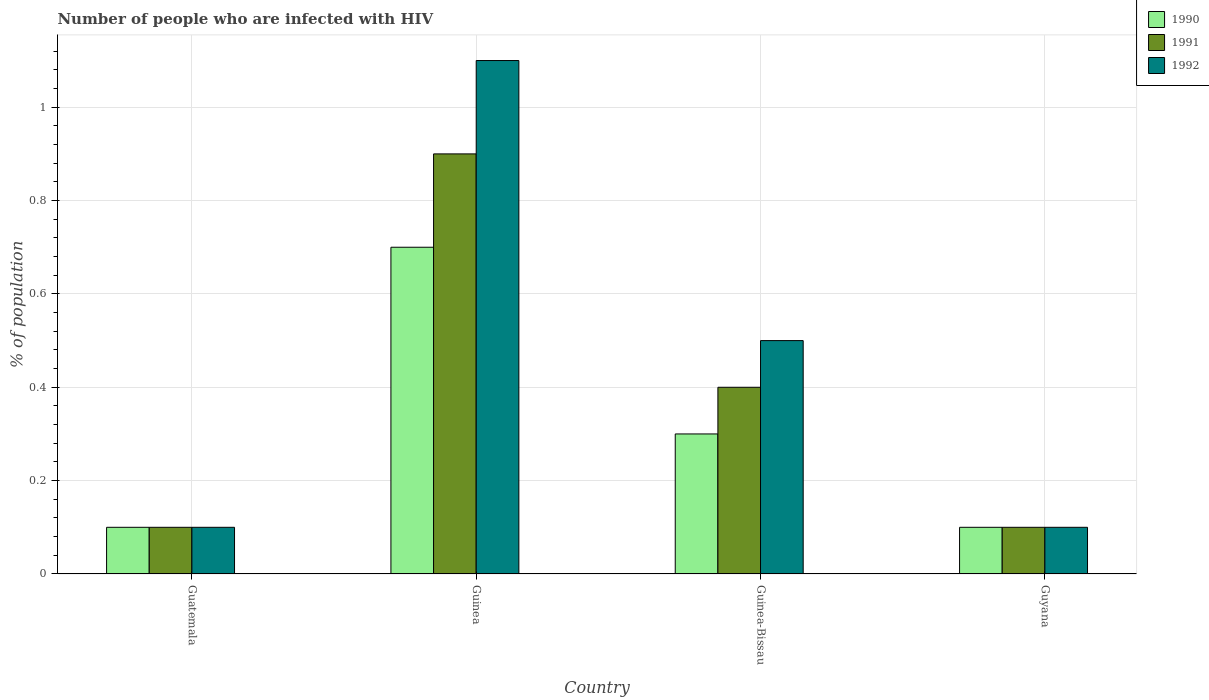How many different coloured bars are there?
Your answer should be compact. 3. How many groups of bars are there?
Keep it short and to the point. 4. Are the number of bars per tick equal to the number of legend labels?
Offer a very short reply. Yes. Are the number of bars on each tick of the X-axis equal?
Offer a terse response. Yes. What is the label of the 2nd group of bars from the left?
Make the answer very short. Guinea. In how many cases, is the number of bars for a given country not equal to the number of legend labels?
Offer a terse response. 0. In which country was the percentage of HIV infected population in in 1990 maximum?
Give a very brief answer. Guinea. In which country was the percentage of HIV infected population in in 1990 minimum?
Your response must be concise. Guatemala. What is the average percentage of HIV infected population in in 1992 per country?
Give a very brief answer. 0.45. What is the difference between the percentage of HIV infected population in of/in 1991 and percentage of HIV infected population in of/in 1992 in Guinea-Bissau?
Give a very brief answer. -0.1. In how many countries, is the percentage of HIV infected population in in 1992 greater than 0.8 %?
Your answer should be compact. 1. What is the ratio of the percentage of HIV infected population in in 1992 in Guatemala to that in Guinea?
Offer a very short reply. 0.09. Is the difference between the percentage of HIV infected population in in 1991 in Guatemala and Guinea-Bissau greater than the difference between the percentage of HIV infected population in in 1992 in Guatemala and Guinea-Bissau?
Make the answer very short. Yes. What is the difference between the highest and the second highest percentage of HIV infected population in in 1992?
Make the answer very short. -0.6. What does the 2nd bar from the left in Guatemala represents?
Ensure brevity in your answer.  1991. What does the 3rd bar from the right in Guatemala represents?
Provide a succinct answer. 1990. Is it the case that in every country, the sum of the percentage of HIV infected population in in 1991 and percentage of HIV infected population in in 1992 is greater than the percentage of HIV infected population in in 1990?
Your answer should be compact. Yes. Are all the bars in the graph horizontal?
Your answer should be very brief. No. How many countries are there in the graph?
Your answer should be compact. 4. Are the values on the major ticks of Y-axis written in scientific E-notation?
Give a very brief answer. No. Where does the legend appear in the graph?
Give a very brief answer. Top right. What is the title of the graph?
Provide a succinct answer. Number of people who are infected with HIV. What is the label or title of the Y-axis?
Ensure brevity in your answer.  % of population. What is the % of population in 1991 in Guatemala?
Provide a short and direct response. 0.1. What is the % of population in 1990 in Guinea?
Ensure brevity in your answer.  0.7. What is the % of population in 1992 in Guyana?
Make the answer very short. 0.1. Across all countries, what is the minimum % of population in 1990?
Your answer should be very brief. 0.1. Across all countries, what is the minimum % of population in 1991?
Your answer should be very brief. 0.1. What is the total % of population in 1990 in the graph?
Give a very brief answer. 1.2. What is the total % of population in 1991 in the graph?
Provide a short and direct response. 1.5. What is the difference between the % of population in 1992 in Guatemala and that in Guinea?
Your answer should be very brief. -1. What is the difference between the % of population of 1990 in Guatemala and that in Guinea-Bissau?
Provide a short and direct response. -0.2. What is the difference between the % of population in 1991 in Guatemala and that in Guyana?
Your answer should be very brief. 0. What is the difference between the % of population in 1992 in Guatemala and that in Guyana?
Make the answer very short. 0. What is the difference between the % of population of 1990 in Guinea and that in Guinea-Bissau?
Give a very brief answer. 0.4. What is the difference between the % of population in 1991 in Guinea and that in Guinea-Bissau?
Your answer should be compact. 0.5. What is the difference between the % of population in 1992 in Guinea and that in Guinea-Bissau?
Give a very brief answer. 0.6. What is the difference between the % of population in 1990 in Guinea and that in Guyana?
Provide a succinct answer. 0.6. What is the difference between the % of population of 1991 in Guinea and that in Guyana?
Your answer should be very brief. 0.8. What is the difference between the % of population of 1992 in Guinea and that in Guyana?
Give a very brief answer. 1. What is the difference between the % of population in 1992 in Guinea-Bissau and that in Guyana?
Keep it short and to the point. 0.4. What is the difference between the % of population in 1990 in Guatemala and the % of population in 1991 in Guinea?
Your response must be concise. -0.8. What is the difference between the % of population in 1991 in Guatemala and the % of population in 1992 in Guinea?
Ensure brevity in your answer.  -1. What is the difference between the % of population in 1990 in Guatemala and the % of population in 1991 in Guyana?
Offer a very short reply. 0. What is the difference between the % of population of 1991 in Guatemala and the % of population of 1992 in Guyana?
Your response must be concise. 0. What is the difference between the % of population of 1990 in Guinea and the % of population of 1992 in Guinea-Bissau?
Offer a terse response. 0.2. What is the difference between the % of population in 1991 in Guinea and the % of population in 1992 in Guinea-Bissau?
Your response must be concise. 0.4. What is the difference between the % of population in 1990 in Guinea and the % of population in 1992 in Guyana?
Your response must be concise. 0.6. What is the difference between the % of population in 1991 in Guinea and the % of population in 1992 in Guyana?
Ensure brevity in your answer.  0.8. What is the difference between the % of population of 1991 in Guinea-Bissau and the % of population of 1992 in Guyana?
Your answer should be very brief. 0.3. What is the average % of population of 1991 per country?
Keep it short and to the point. 0.38. What is the average % of population of 1992 per country?
Ensure brevity in your answer.  0.45. What is the difference between the % of population of 1990 and % of population of 1991 in Guatemala?
Give a very brief answer. 0. What is the difference between the % of population in 1991 and % of population in 1992 in Guatemala?
Give a very brief answer. 0. What is the difference between the % of population of 1990 and % of population of 1991 in Guinea?
Your answer should be compact. -0.2. What is the difference between the % of population in 1990 and % of population in 1992 in Guinea?
Your answer should be very brief. -0.4. What is the difference between the % of population in 1990 and % of population in 1991 in Guinea-Bissau?
Make the answer very short. -0.1. What is the difference between the % of population of 1991 and % of population of 1992 in Guinea-Bissau?
Give a very brief answer. -0.1. What is the ratio of the % of population of 1990 in Guatemala to that in Guinea?
Your answer should be compact. 0.14. What is the ratio of the % of population in 1991 in Guatemala to that in Guinea?
Offer a terse response. 0.11. What is the ratio of the % of population in 1992 in Guatemala to that in Guinea?
Your response must be concise. 0.09. What is the ratio of the % of population of 1990 in Guatemala to that in Guinea-Bissau?
Keep it short and to the point. 0.33. What is the ratio of the % of population of 1991 in Guatemala to that in Guinea-Bissau?
Your answer should be very brief. 0.25. What is the ratio of the % of population in 1990 in Guatemala to that in Guyana?
Your answer should be very brief. 1. What is the ratio of the % of population in 1991 in Guatemala to that in Guyana?
Your response must be concise. 1. What is the ratio of the % of population in 1992 in Guatemala to that in Guyana?
Offer a terse response. 1. What is the ratio of the % of population of 1990 in Guinea to that in Guinea-Bissau?
Make the answer very short. 2.33. What is the ratio of the % of population in 1991 in Guinea to that in Guinea-Bissau?
Keep it short and to the point. 2.25. What is the ratio of the % of population in 1992 in Guinea to that in Guinea-Bissau?
Your answer should be compact. 2.2. What is the ratio of the % of population in 1990 in Guinea to that in Guyana?
Your response must be concise. 7. What is the ratio of the % of population in 1992 in Guinea to that in Guyana?
Offer a terse response. 11. What is the ratio of the % of population in 1991 in Guinea-Bissau to that in Guyana?
Your answer should be compact. 4. What is the ratio of the % of population in 1992 in Guinea-Bissau to that in Guyana?
Make the answer very short. 5. What is the difference between the highest and the second highest % of population of 1991?
Offer a very short reply. 0.5. What is the difference between the highest and the lowest % of population in 1992?
Your answer should be very brief. 1. 